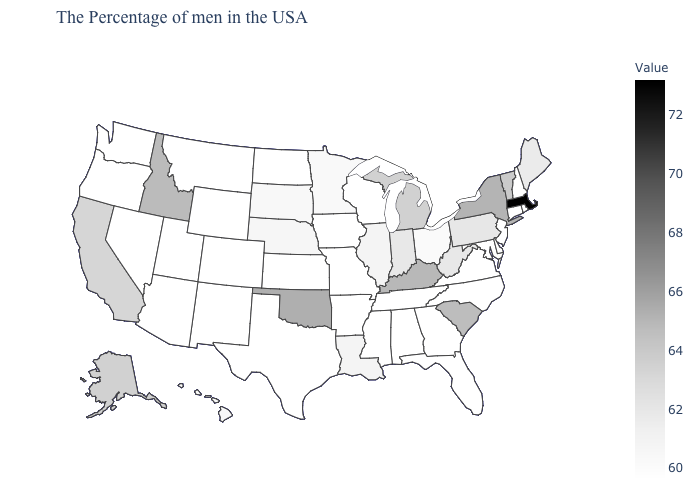Which states have the lowest value in the South?
Short answer required. Delaware, Maryland, Virginia, North Carolina, Florida, Georgia, Alabama, Tennessee, Mississippi, Arkansas, Texas. Among the states that border New Mexico , which have the lowest value?
Keep it brief. Texas, Colorado, Utah, Arizona. Among the states that border Delaware , which have the lowest value?
Quick response, please. New Jersey, Maryland. Does Massachusetts have the highest value in the USA?
Quick response, please. Yes. Does the map have missing data?
Be succinct. No. Which states have the lowest value in the Northeast?
Concise answer only. Rhode Island, New Hampshire, Connecticut, New Jersey. Which states have the lowest value in the USA?
Quick response, please. Rhode Island, New Hampshire, Connecticut, New Jersey, Delaware, Maryland, Virginia, North Carolina, Florida, Georgia, Alabama, Tennessee, Wisconsin, Mississippi, Missouri, Arkansas, Iowa, Kansas, Texas, North Dakota, Wyoming, Colorado, New Mexico, Utah, Montana, Arizona, Nevada, Washington, Oregon. Does Oregon have the lowest value in the West?
Answer briefly. Yes. 